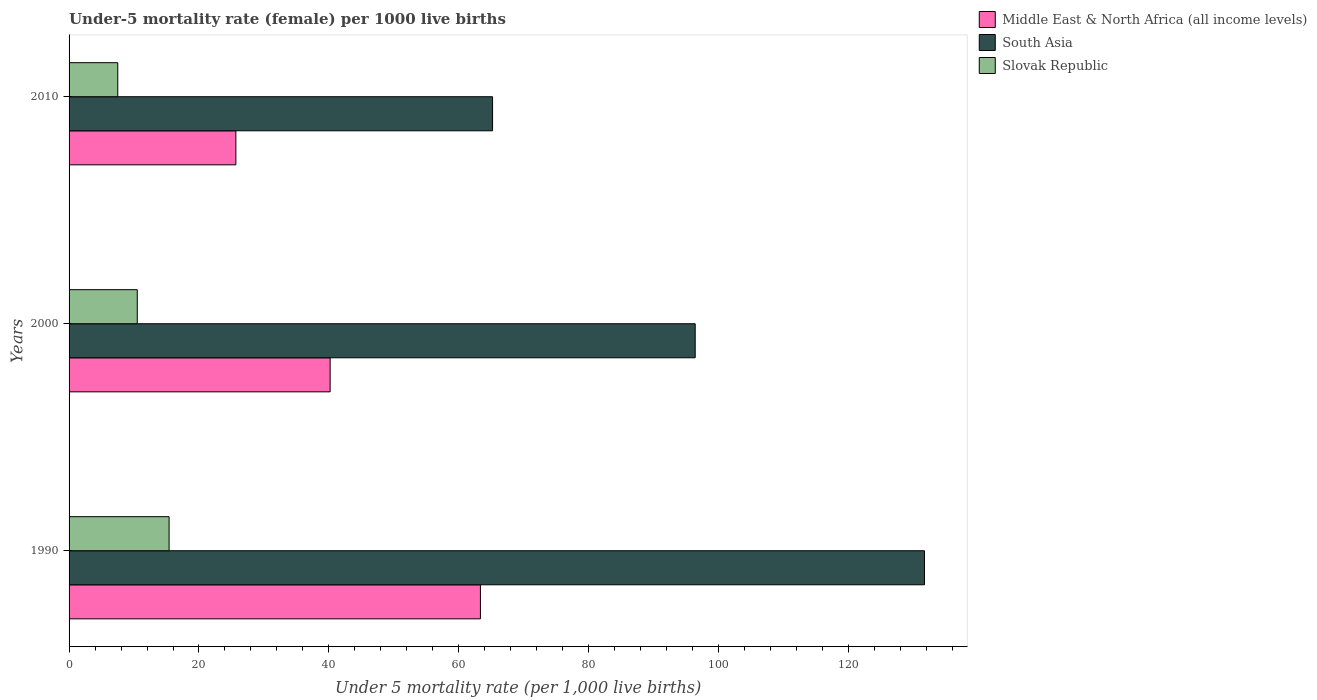How many groups of bars are there?
Offer a very short reply. 3. Are the number of bars on each tick of the Y-axis equal?
Offer a terse response. Yes. How many bars are there on the 2nd tick from the top?
Make the answer very short. 3. How many bars are there on the 2nd tick from the bottom?
Your response must be concise. 3. In how many cases, is the number of bars for a given year not equal to the number of legend labels?
Offer a terse response. 0. What is the under-five mortality rate in Slovak Republic in 2000?
Your answer should be compact. 10.5. Across all years, what is the maximum under-five mortality rate in Middle East & North Africa (all income levels)?
Ensure brevity in your answer.  63.33. Across all years, what is the minimum under-five mortality rate in South Asia?
Provide a short and direct response. 65.2. In which year was the under-five mortality rate in Slovak Republic minimum?
Provide a short and direct response. 2010. What is the total under-five mortality rate in Slovak Republic in the graph?
Offer a very short reply. 33.4. What is the difference between the under-five mortality rate in South Asia in 1990 and the under-five mortality rate in Slovak Republic in 2000?
Make the answer very short. 121.2. What is the average under-five mortality rate in Middle East & North Africa (all income levels) per year?
Provide a short and direct response. 43.07. In the year 2000, what is the difference between the under-five mortality rate in South Asia and under-five mortality rate in Middle East & North Africa (all income levels)?
Your answer should be very brief. 56.2. In how many years, is the under-five mortality rate in Slovak Republic greater than 92 ?
Offer a terse response. 0. What is the ratio of the under-five mortality rate in South Asia in 2000 to that in 2010?
Offer a very short reply. 1.48. What is the difference between the highest and the lowest under-five mortality rate in Middle East & North Africa (all income levels)?
Your response must be concise. 37.65. What does the 3rd bar from the bottom in 2000 represents?
Give a very brief answer. Slovak Republic. Is it the case that in every year, the sum of the under-five mortality rate in Middle East & North Africa (all income levels) and under-five mortality rate in South Asia is greater than the under-five mortality rate in Slovak Republic?
Provide a short and direct response. Yes. How many bars are there?
Give a very brief answer. 9. How many years are there in the graph?
Make the answer very short. 3. What is the difference between two consecutive major ticks on the X-axis?
Your answer should be compact. 20. Are the values on the major ticks of X-axis written in scientific E-notation?
Offer a terse response. No. Does the graph contain grids?
Give a very brief answer. No. What is the title of the graph?
Provide a succinct answer. Under-5 mortality rate (female) per 1000 live births. Does "Latin America(developing only)" appear as one of the legend labels in the graph?
Your response must be concise. No. What is the label or title of the X-axis?
Give a very brief answer. Under 5 mortality rate (per 1,0 live births). What is the label or title of the Y-axis?
Provide a short and direct response. Years. What is the Under 5 mortality rate (per 1,000 live births) in Middle East & North Africa (all income levels) in 1990?
Give a very brief answer. 63.33. What is the Under 5 mortality rate (per 1,000 live births) of South Asia in 1990?
Ensure brevity in your answer.  131.7. What is the Under 5 mortality rate (per 1,000 live births) of Slovak Republic in 1990?
Your answer should be compact. 15.4. What is the Under 5 mortality rate (per 1,000 live births) in Middle East & North Africa (all income levels) in 2000?
Make the answer very short. 40.2. What is the Under 5 mortality rate (per 1,000 live births) in South Asia in 2000?
Give a very brief answer. 96.4. What is the Under 5 mortality rate (per 1,000 live births) in Slovak Republic in 2000?
Your response must be concise. 10.5. What is the Under 5 mortality rate (per 1,000 live births) of Middle East & North Africa (all income levels) in 2010?
Give a very brief answer. 25.68. What is the Under 5 mortality rate (per 1,000 live births) of South Asia in 2010?
Offer a very short reply. 65.2. Across all years, what is the maximum Under 5 mortality rate (per 1,000 live births) of Middle East & North Africa (all income levels)?
Offer a very short reply. 63.33. Across all years, what is the maximum Under 5 mortality rate (per 1,000 live births) of South Asia?
Make the answer very short. 131.7. Across all years, what is the minimum Under 5 mortality rate (per 1,000 live births) in Middle East & North Africa (all income levels)?
Your response must be concise. 25.68. Across all years, what is the minimum Under 5 mortality rate (per 1,000 live births) of South Asia?
Provide a succinct answer. 65.2. What is the total Under 5 mortality rate (per 1,000 live births) in Middle East & North Africa (all income levels) in the graph?
Ensure brevity in your answer.  129.21. What is the total Under 5 mortality rate (per 1,000 live births) of South Asia in the graph?
Your answer should be very brief. 293.3. What is the total Under 5 mortality rate (per 1,000 live births) in Slovak Republic in the graph?
Offer a very short reply. 33.4. What is the difference between the Under 5 mortality rate (per 1,000 live births) in Middle East & North Africa (all income levels) in 1990 and that in 2000?
Give a very brief answer. 23.14. What is the difference between the Under 5 mortality rate (per 1,000 live births) in South Asia in 1990 and that in 2000?
Provide a short and direct response. 35.3. What is the difference between the Under 5 mortality rate (per 1,000 live births) of Slovak Republic in 1990 and that in 2000?
Ensure brevity in your answer.  4.9. What is the difference between the Under 5 mortality rate (per 1,000 live births) of Middle East & North Africa (all income levels) in 1990 and that in 2010?
Your response must be concise. 37.65. What is the difference between the Under 5 mortality rate (per 1,000 live births) in South Asia in 1990 and that in 2010?
Keep it short and to the point. 66.5. What is the difference between the Under 5 mortality rate (per 1,000 live births) in Middle East & North Africa (all income levels) in 2000 and that in 2010?
Keep it short and to the point. 14.51. What is the difference between the Under 5 mortality rate (per 1,000 live births) of South Asia in 2000 and that in 2010?
Your response must be concise. 31.2. What is the difference between the Under 5 mortality rate (per 1,000 live births) in Slovak Republic in 2000 and that in 2010?
Your answer should be compact. 3. What is the difference between the Under 5 mortality rate (per 1,000 live births) of Middle East & North Africa (all income levels) in 1990 and the Under 5 mortality rate (per 1,000 live births) of South Asia in 2000?
Keep it short and to the point. -33.07. What is the difference between the Under 5 mortality rate (per 1,000 live births) in Middle East & North Africa (all income levels) in 1990 and the Under 5 mortality rate (per 1,000 live births) in Slovak Republic in 2000?
Give a very brief answer. 52.83. What is the difference between the Under 5 mortality rate (per 1,000 live births) in South Asia in 1990 and the Under 5 mortality rate (per 1,000 live births) in Slovak Republic in 2000?
Offer a terse response. 121.2. What is the difference between the Under 5 mortality rate (per 1,000 live births) of Middle East & North Africa (all income levels) in 1990 and the Under 5 mortality rate (per 1,000 live births) of South Asia in 2010?
Provide a succinct answer. -1.87. What is the difference between the Under 5 mortality rate (per 1,000 live births) of Middle East & North Africa (all income levels) in 1990 and the Under 5 mortality rate (per 1,000 live births) of Slovak Republic in 2010?
Ensure brevity in your answer.  55.83. What is the difference between the Under 5 mortality rate (per 1,000 live births) of South Asia in 1990 and the Under 5 mortality rate (per 1,000 live births) of Slovak Republic in 2010?
Offer a terse response. 124.2. What is the difference between the Under 5 mortality rate (per 1,000 live births) in Middle East & North Africa (all income levels) in 2000 and the Under 5 mortality rate (per 1,000 live births) in South Asia in 2010?
Provide a succinct answer. -25. What is the difference between the Under 5 mortality rate (per 1,000 live births) in Middle East & North Africa (all income levels) in 2000 and the Under 5 mortality rate (per 1,000 live births) in Slovak Republic in 2010?
Offer a terse response. 32.7. What is the difference between the Under 5 mortality rate (per 1,000 live births) of South Asia in 2000 and the Under 5 mortality rate (per 1,000 live births) of Slovak Republic in 2010?
Provide a short and direct response. 88.9. What is the average Under 5 mortality rate (per 1,000 live births) of Middle East & North Africa (all income levels) per year?
Make the answer very short. 43.07. What is the average Under 5 mortality rate (per 1,000 live births) of South Asia per year?
Provide a succinct answer. 97.77. What is the average Under 5 mortality rate (per 1,000 live births) in Slovak Republic per year?
Offer a terse response. 11.13. In the year 1990, what is the difference between the Under 5 mortality rate (per 1,000 live births) in Middle East & North Africa (all income levels) and Under 5 mortality rate (per 1,000 live births) in South Asia?
Keep it short and to the point. -68.37. In the year 1990, what is the difference between the Under 5 mortality rate (per 1,000 live births) of Middle East & North Africa (all income levels) and Under 5 mortality rate (per 1,000 live births) of Slovak Republic?
Your response must be concise. 47.93. In the year 1990, what is the difference between the Under 5 mortality rate (per 1,000 live births) in South Asia and Under 5 mortality rate (per 1,000 live births) in Slovak Republic?
Make the answer very short. 116.3. In the year 2000, what is the difference between the Under 5 mortality rate (per 1,000 live births) of Middle East & North Africa (all income levels) and Under 5 mortality rate (per 1,000 live births) of South Asia?
Provide a succinct answer. -56.2. In the year 2000, what is the difference between the Under 5 mortality rate (per 1,000 live births) in Middle East & North Africa (all income levels) and Under 5 mortality rate (per 1,000 live births) in Slovak Republic?
Provide a short and direct response. 29.7. In the year 2000, what is the difference between the Under 5 mortality rate (per 1,000 live births) of South Asia and Under 5 mortality rate (per 1,000 live births) of Slovak Republic?
Your answer should be compact. 85.9. In the year 2010, what is the difference between the Under 5 mortality rate (per 1,000 live births) in Middle East & North Africa (all income levels) and Under 5 mortality rate (per 1,000 live births) in South Asia?
Offer a terse response. -39.52. In the year 2010, what is the difference between the Under 5 mortality rate (per 1,000 live births) in Middle East & North Africa (all income levels) and Under 5 mortality rate (per 1,000 live births) in Slovak Republic?
Ensure brevity in your answer.  18.18. In the year 2010, what is the difference between the Under 5 mortality rate (per 1,000 live births) in South Asia and Under 5 mortality rate (per 1,000 live births) in Slovak Republic?
Your answer should be very brief. 57.7. What is the ratio of the Under 5 mortality rate (per 1,000 live births) in Middle East & North Africa (all income levels) in 1990 to that in 2000?
Make the answer very short. 1.58. What is the ratio of the Under 5 mortality rate (per 1,000 live births) of South Asia in 1990 to that in 2000?
Make the answer very short. 1.37. What is the ratio of the Under 5 mortality rate (per 1,000 live births) of Slovak Republic in 1990 to that in 2000?
Keep it short and to the point. 1.47. What is the ratio of the Under 5 mortality rate (per 1,000 live births) of Middle East & North Africa (all income levels) in 1990 to that in 2010?
Your answer should be very brief. 2.47. What is the ratio of the Under 5 mortality rate (per 1,000 live births) in South Asia in 1990 to that in 2010?
Make the answer very short. 2.02. What is the ratio of the Under 5 mortality rate (per 1,000 live births) of Slovak Republic in 1990 to that in 2010?
Ensure brevity in your answer.  2.05. What is the ratio of the Under 5 mortality rate (per 1,000 live births) in Middle East & North Africa (all income levels) in 2000 to that in 2010?
Give a very brief answer. 1.57. What is the ratio of the Under 5 mortality rate (per 1,000 live births) of South Asia in 2000 to that in 2010?
Give a very brief answer. 1.48. What is the difference between the highest and the second highest Under 5 mortality rate (per 1,000 live births) of Middle East & North Africa (all income levels)?
Offer a very short reply. 23.14. What is the difference between the highest and the second highest Under 5 mortality rate (per 1,000 live births) in South Asia?
Ensure brevity in your answer.  35.3. What is the difference between the highest and the second highest Under 5 mortality rate (per 1,000 live births) of Slovak Republic?
Make the answer very short. 4.9. What is the difference between the highest and the lowest Under 5 mortality rate (per 1,000 live births) of Middle East & North Africa (all income levels)?
Your answer should be compact. 37.65. What is the difference between the highest and the lowest Under 5 mortality rate (per 1,000 live births) of South Asia?
Offer a terse response. 66.5. What is the difference between the highest and the lowest Under 5 mortality rate (per 1,000 live births) in Slovak Republic?
Ensure brevity in your answer.  7.9. 